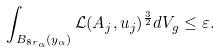Convert formula to latex. <formula><loc_0><loc_0><loc_500><loc_500>\int _ { B _ { 8 r _ { \alpha } } ( y _ { \alpha } ) } \mathcal { L } ( A _ { j } , u _ { j } ) ^ { \frac { 3 } { 2 } } d V _ { g } \leq \varepsilon .</formula> 